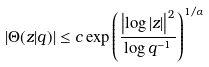Convert formula to latex. <formula><loc_0><loc_0><loc_500><loc_500>| \Theta ( z | q ) | \leq c \exp \left ( \frac { \left | \log | z | \right | ^ { 2 } } { \log q ^ { - 1 } } \right ) ^ { 1 / \alpha }</formula> 